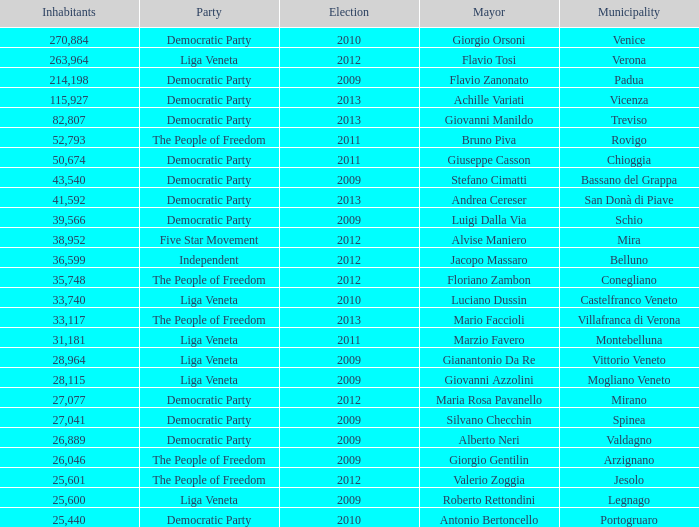How many residents participated in the democratic party for a mayoral election before 2009 for stefano cimatti? 0.0. 